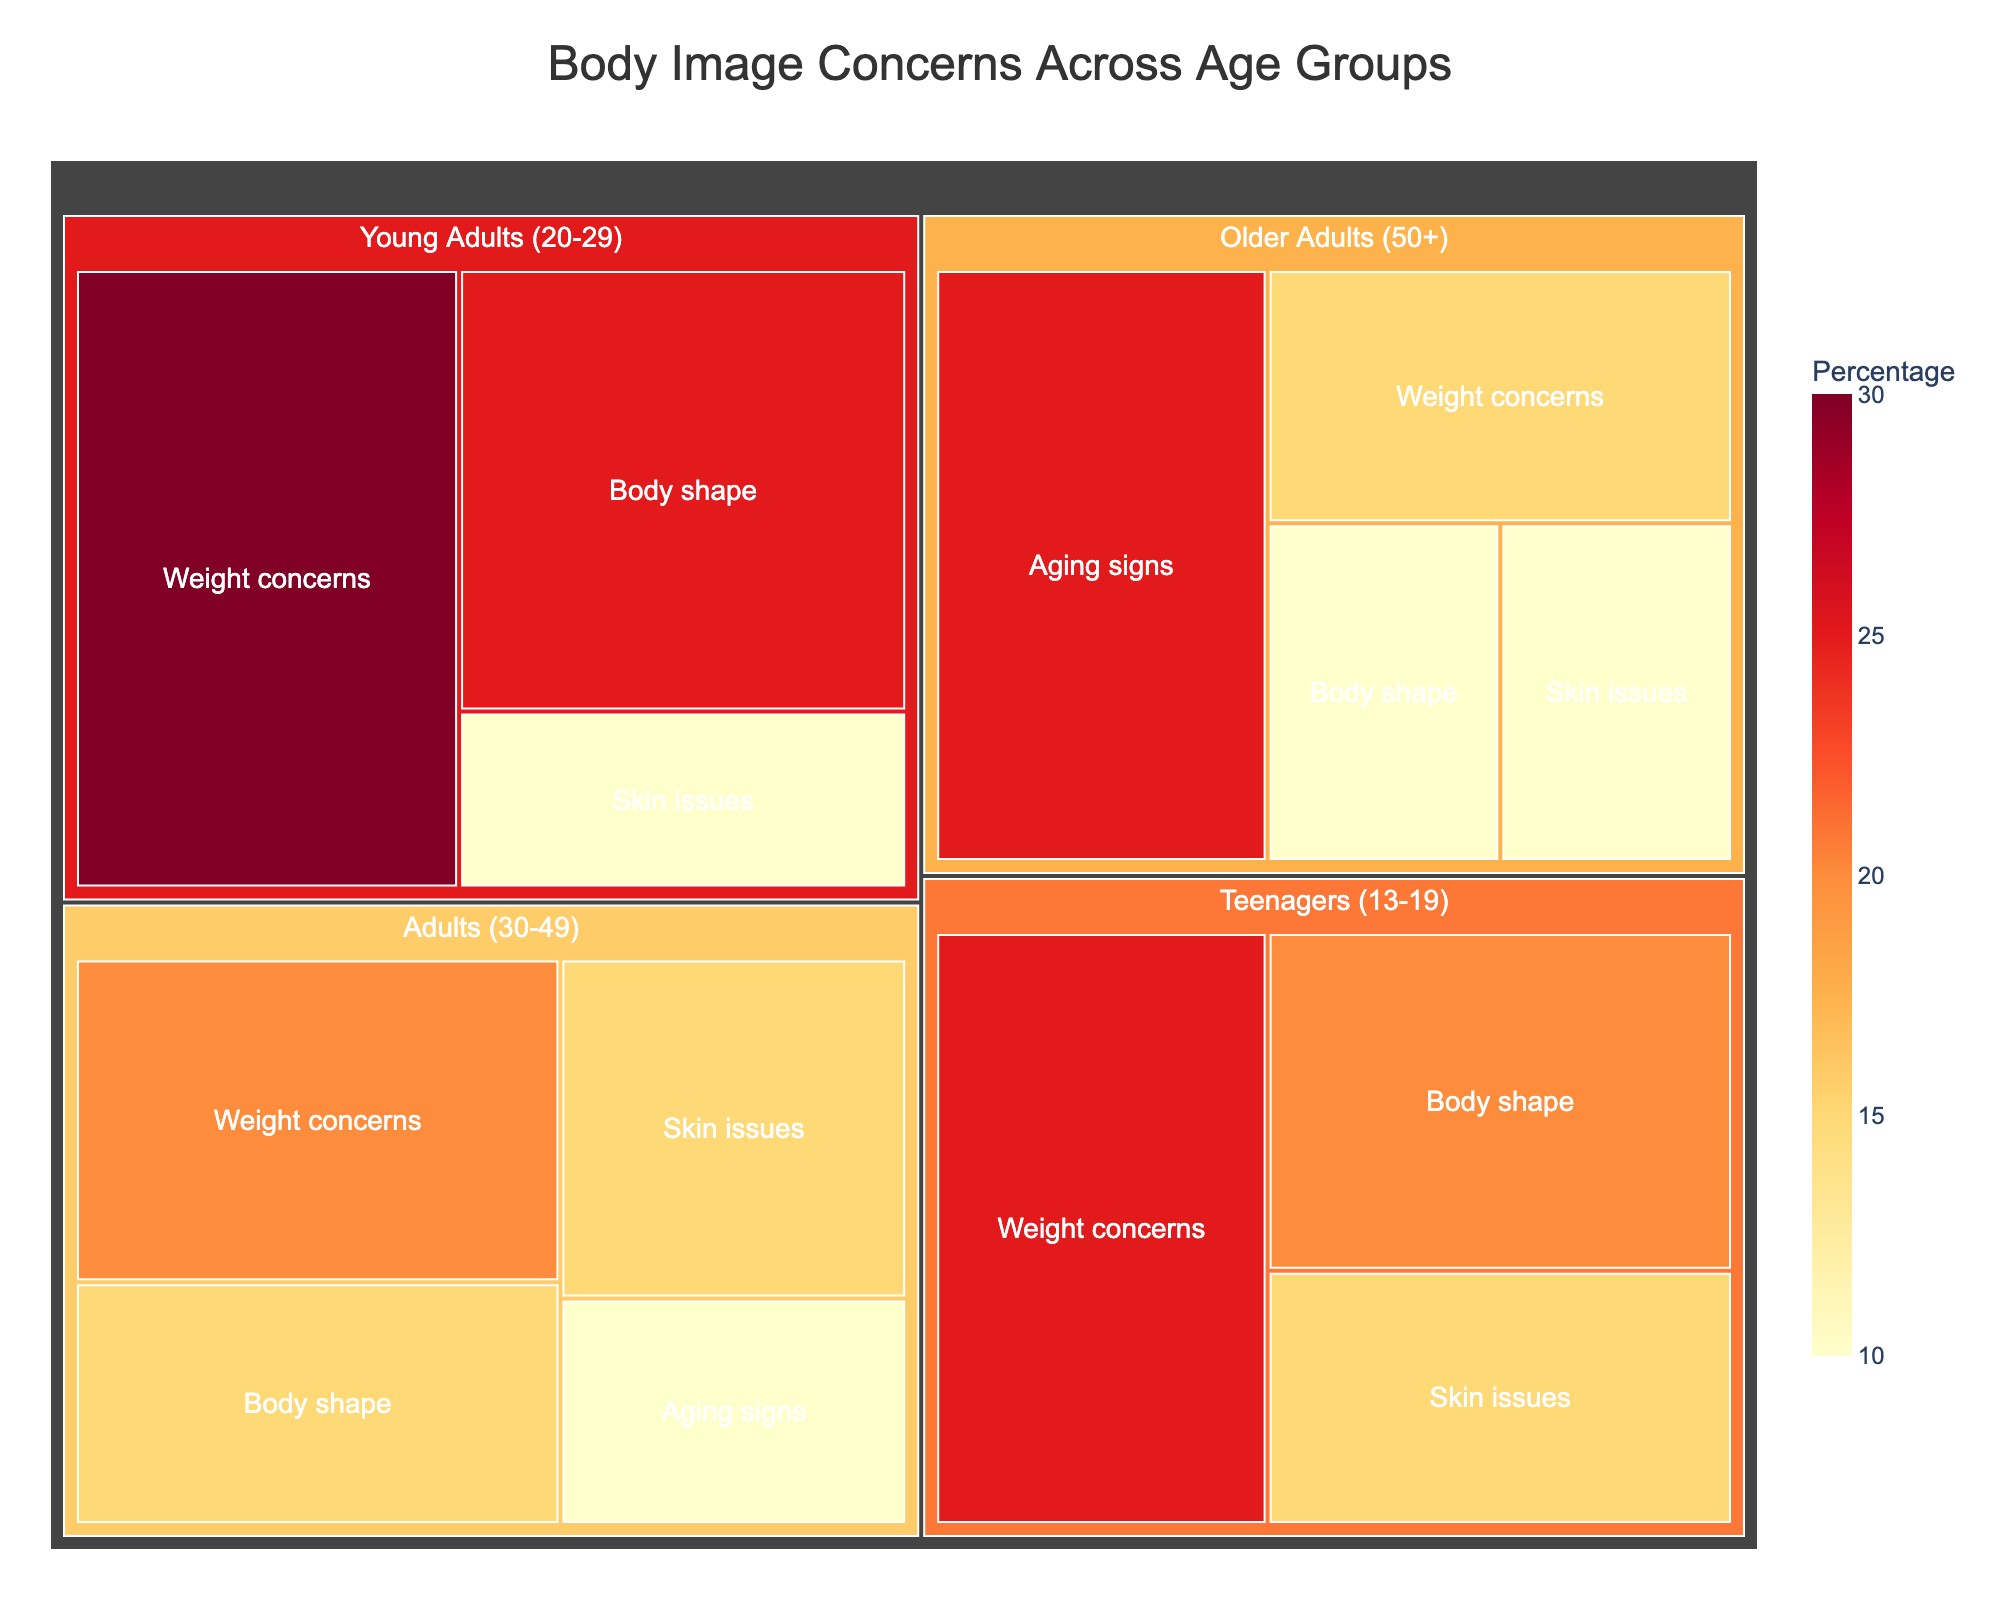What's the title of the treemap? The title is displayed at the top of the treemap.
Answer: Body Image Concerns Across Age Groups Which age group has the highest percentage of body shape concerns? Look for the subgroup "Body shape" under each age category and compare their percentages.
Answer: Young Adults (20-29) with 25% What is the total percentage of weight concerns across all age groups? Add the weight concerns percentages for all age groups: 25 (Teenagers) + 30 (Young Adults) + 20 (Adults) + 15 (Older Adults).
Answer: 90% Between Teenagers and Young Adults, which group is more concerned about skin issues? Compare the percentages for the subgroup "Skin issues" in both Teenagers and Young Adults.
Answer: Teenagers (15%) What percentage of Older Adults are concerned about aging signs? Look for the "Aging signs" subgroup under the Older Adults category.
Answer: 25% What is the combined percentage of body shape concerns for Adults (30-49) and Older Adults (50+)? Add the body shape concerns percentages for Adults and Older Adults: 15 (Adults) + 10 (Older Adults).
Answer: 25% Which subgroup within Teenagers (13-19) has the second highest percentage of concerns? Compare the subgroups under Teenagers and identify the one with the second highest percentage.
Answer: Body shape (20%) Which age group is less concerned about their skin issues, Adults (30-49) or Older Adults (50+)? Compare the "Skin issues" percentages for Adults and Older Adults.
Answer: Older Adults (10%) How does the percentage of weight concerns in Young Adults (20-29) compare to that in Adults (30-49)? Subtract the weight concerns percentage in Adults from that in Young Adults: 30 (Young Adults) - 20 (Adults).
Answer: 10% higher Which concern category appears only in the Adults (30-49) and Older Adults (50+) groups? Identify the unique subgroup that is present only in Adults and Older Adults.
Answer: Aging signs 